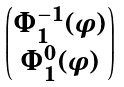<formula> <loc_0><loc_0><loc_500><loc_500>\begin{pmatrix} \Phi _ { 1 } ^ { - 1 } ( \varphi ) \\ \Phi _ { 1 } ^ { 0 } ( \varphi ) \end{pmatrix}</formula> 